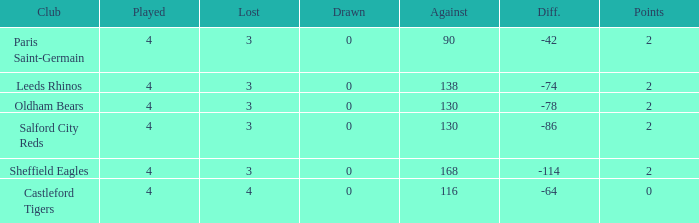For teams with under 4 games played, what is the combined sum of their losses? None. Can you give me this table as a dict? {'header': ['Club', 'Played', 'Lost', 'Drawn', 'Against', 'Diff.', 'Points'], 'rows': [['Paris Saint-Germain', '4', '3', '0', '90', '-42', '2'], ['Leeds Rhinos', '4', '3', '0', '138', '-74', '2'], ['Oldham Bears', '4', '3', '0', '130', '-78', '2'], ['Salford City Reds', '4', '3', '0', '130', '-86', '2'], ['Sheffield Eagles', '4', '3', '0', '168', '-114', '2'], ['Castleford Tigers', '4', '4', '0', '116', '-64', '0']]} 